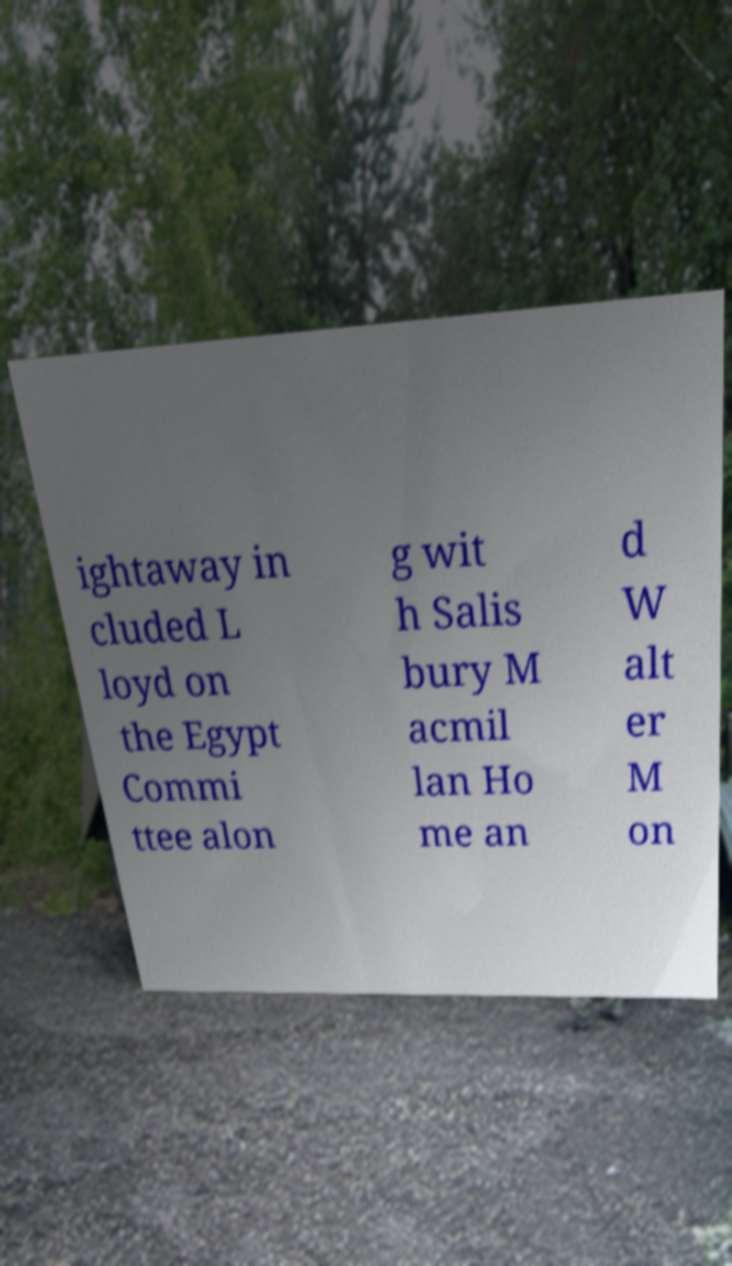Could you extract and type out the text from this image? ightaway in cluded L loyd on the Egypt Commi ttee alon g wit h Salis bury M acmil lan Ho me an d W alt er M on 